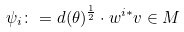<formula> <loc_0><loc_0><loc_500><loc_500>\psi _ { i } \colon = d ( \theta ) ^ { \frac { 1 } { 2 } } \cdot w ^ { i * } v \in M</formula> 